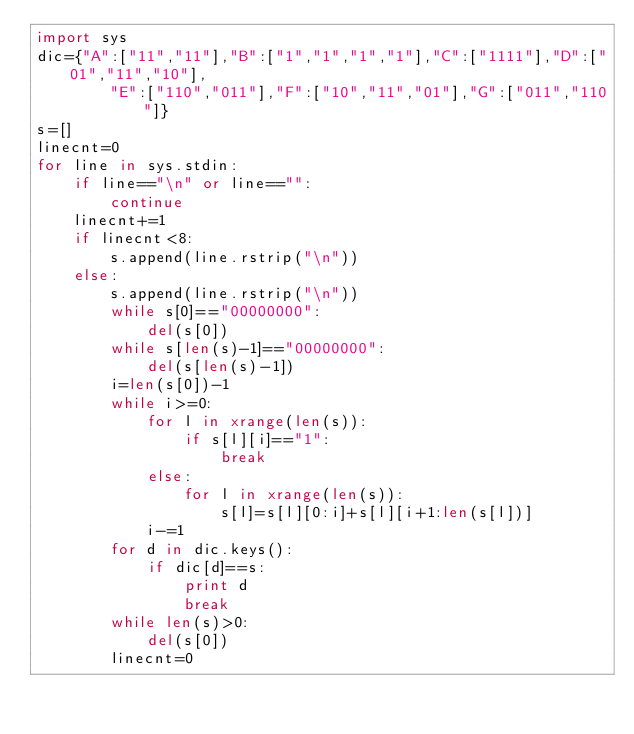Convert code to text. <code><loc_0><loc_0><loc_500><loc_500><_Python_>import sys
dic={"A":["11","11"],"B":["1","1","1","1"],"C":["1111"],"D":["01","11","10"],
		"E":["110","011"],"F":["10","11","01"],"G":["011","110"]}
s=[]
linecnt=0
for line in sys.stdin:
	if line=="\n" or line=="":
		continue
	linecnt+=1
	if linecnt<8:
		s.append(line.rstrip("\n"))
	else:
		s.append(line.rstrip("\n"))
		while s[0]=="00000000":
			del(s[0])
		while s[len(s)-1]=="00000000":
			del(s[len(s)-1])
		i=len(s[0])-1
		while i>=0:
			for l in xrange(len(s)):
				if s[l][i]=="1":
					break
			else:
				for l in xrange(len(s)):
					s[l]=s[l][0:i]+s[l][i+1:len(s[l])]
			i-=1
		for d in dic.keys():
			if dic[d]==s:
				print d
				break
		while len(s)>0:
			del(s[0])
		linecnt=0</code> 